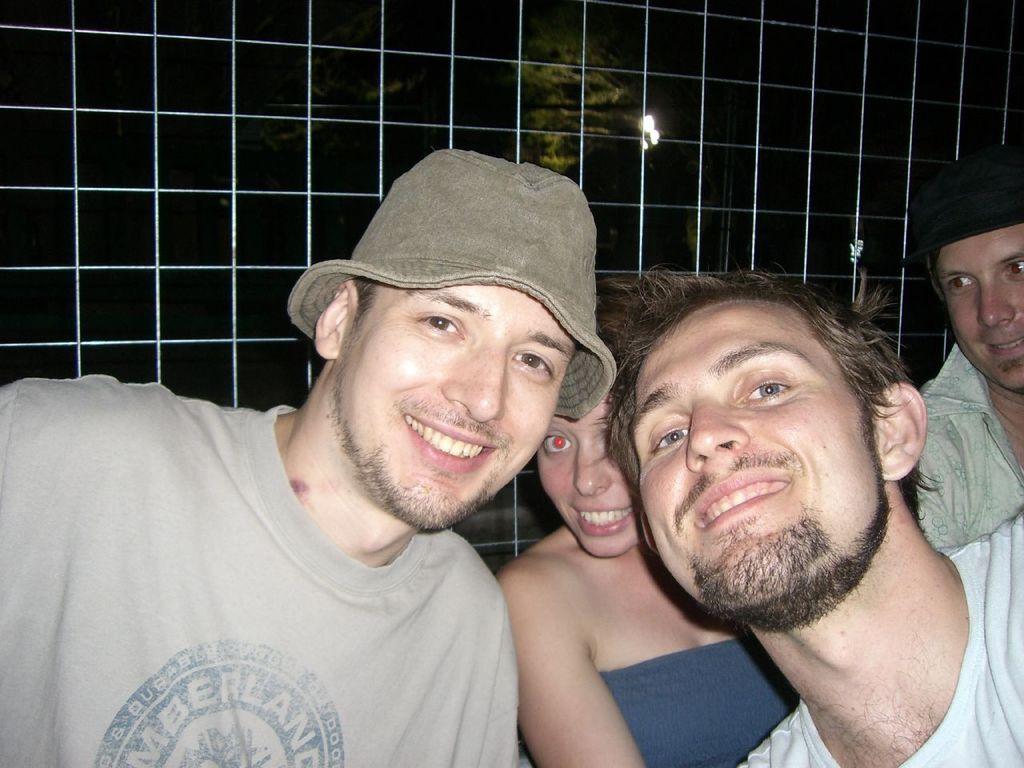In one or two sentences, can you explain what this image depicts? Here I can see three men and a woman are smiling and giving pose for the picture. At the back of these people there is a net. In the background, I can see a tree and a light in the dark. 